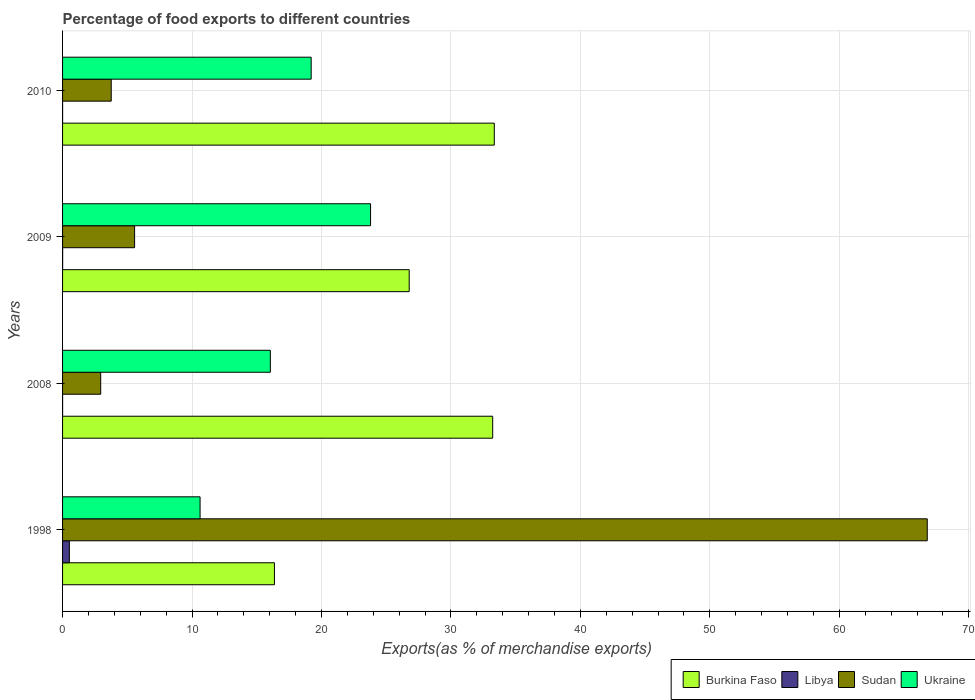How many different coloured bars are there?
Ensure brevity in your answer.  4. How many groups of bars are there?
Your response must be concise. 4. How many bars are there on the 1st tick from the top?
Make the answer very short. 4. What is the percentage of exports to different countries in Sudan in 2010?
Keep it short and to the point. 3.76. Across all years, what is the maximum percentage of exports to different countries in Ukraine?
Keep it short and to the point. 23.79. Across all years, what is the minimum percentage of exports to different countries in Sudan?
Provide a succinct answer. 2.95. In which year was the percentage of exports to different countries in Burkina Faso maximum?
Give a very brief answer. 2010. What is the total percentage of exports to different countries in Ukraine in the graph?
Offer a terse response. 69.66. What is the difference between the percentage of exports to different countries in Burkina Faso in 1998 and that in 2008?
Offer a terse response. -16.86. What is the difference between the percentage of exports to different countries in Burkina Faso in 2008 and the percentage of exports to different countries in Sudan in 1998?
Provide a short and direct response. -33.57. What is the average percentage of exports to different countries in Ukraine per year?
Your answer should be compact. 17.42. In the year 2008, what is the difference between the percentage of exports to different countries in Ukraine and percentage of exports to different countries in Libya?
Provide a short and direct response. 16.05. What is the ratio of the percentage of exports to different countries in Sudan in 2009 to that in 2010?
Provide a short and direct response. 1.48. What is the difference between the highest and the second highest percentage of exports to different countries in Burkina Faso?
Your answer should be very brief. 0.12. What is the difference between the highest and the lowest percentage of exports to different countries in Sudan?
Your answer should be very brief. 63.85. In how many years, is the percentage of exports to different countries in Sudan greater than the average percentage of exports to different countries in Sudan taken over all years?
Your response must be concise. 1. Is the sum of the percentage of exports to different countries in Sudan in 1998 and 2010 greater than the maximum percentage of exports to different countries in Ukraine across all years?
Your answer should be compact. Yes. Is it the case that in every year, the sum of the percentage of exports to different countries in Ukraine and percentage of exports to different countries in Burkina Faso is greater than the sum of percentage of exports to different countries in Libya and percentage of exports to different countries in Sudan?
Offer a very short reply. Yes. What does the 2nd bar from the top in 2010 represents?
Keep it short and to the point. Sudan. What does the 2nd bar from the bottom in 2009 represents?
Your answer should be very brief. Libya. Is it the case that in every year, the sum of the percentage of exports to different countries in Libya and percentage of exports to different countries in Sudan is greater than the percentage of exports to different countries in Burkina Faso?
Ensure brevity in your answer.  No. How many bars are there?
Give a very brief answer. 16. Does the graph contain grids?
Your answer should be compact. Yes. Where does the legend appear in the graph?
Provide a short and direct response. Bottom right. How many legend labels are there?
Provide a succinct answer. 4. What is the title of the graph?
Offer a terse response. Percentage of food exports to different countries. What is the label or title of the X-axis?
Provide a succinct answer. Exports(as % of merchandise exports). What is the Exports(as % of merchandise exports) in Burkina Faso in 1998?
Give a very brief answer. 16.37. What is the Exports(as % of merchandise exports) of Libya in 1998?
Provide a short and direct response. 0.53. What is the Exports(as % of merchandise exports) of Sudan in 1998?
Your answer should be very brief. 66.79. What is the Exports(as % of merchandise exports) in Ukraine in 1998?
Provide a short and direct response. 10.62. What is the Exports(as % of merchandise exports) of Burkina Faso in 2008?
Keep it short and to the point. 33.22. What is the Exports(as % of merchandise exports) in Libya in 2008?
Offer a very short reply. 0. What is the Exports(as % of merchandise exports) of Sudan in 2008?
Ensure brevity in your answer.  2.95. What is the Exports(as % of merchandise exports) of Ukraine in 2008?
Provide a succinct answer. 16.05. What is the Exports(as % of merchandise exports) of Burkina Faso in 2009?
Offer a terse response. 26.78. What is the Exports(as % of merchandise exports) of Libya in 2009?
Keep it short and to the point. 0.01. What is the Exports(as % of merchandise exports) of Sudan in 2009?
Offer a very short reply. 5.56. What is the Exports(as % of merchandise exports) of Ukraine in 2009?
Provide a succinct answer. 23.79. What is the Exports(as % of merchandise exports) of Burkina Faso in 2010?
Make the answer very short. 33.35. What is the Exports(as % of merchandise exports) of Libya in 2010?
Ensure brevity in your answer.  0. What is the Exports(as % of merchandise exports) in Sudan in 2010?
Ensure brevity in your answer.  3.76. What is the Exports(as % of merchandise exports) of Ukraine in 2010?
Make the answer very short. 19.2. Across all years, what is the maximum Exports(as % of merchandise exports) in Burkina Faso?
Provide a short and direct response. 33.35. Across all years, what is the maximum Exports(as % of merchandise exports) of Libya?
Provide a short and direct response. 0.53. Across all years, what is the maximum Exports(as % of merchandise exports) of Sudan?
Ensure brevity in your answer.  66.79. Across all years, what is the maximum Exports(as % of merchandise exports) in Ukraine?
Ensure brevity in your answer.  23.79. Across all years, what is the minimum Exports(as % of merchandise exports) in Burkina Faso?
Ensure brevity in your answer.  16.37. Across all years, what is the minimum Exports(as % of merchandise exports) in Libya?
Keep it short and to the point. 0. Across all years, what is the minimum Exports(as % of merchandise exports) of Sudan?
Provide a short and direct response. 2.95. Across all years, what is the minimum Exports(as % of merchandise exports) in Ukraine?
Your answer should be very brief. 10.62. What is the total Exports(as % of merchandise exports) of Burkina Faso in the graph?
Your answer should be very brief. 109.71. What is the total Exports(as % of merchandise exports) in Libya in the graph?
Your answer should be compact. 0.54. What is the total Exports(as % of merchandise exports) in Sudan in the graph?
Offer a very short reply. 79.06. What is the total Exports(as % of merchandise exports) of Ukraine in the graph?
Provide a short and direct response. 69.66. What is the difference between the Exports(as % of merchandise exports) of Burkina Faso in 1998 and that in 2008?
Your answer should be very brief. -16.86. What is the difference between the Exports(as % of merchandise exports) in Libya in 1998 and that in 2008?
Provide a succinct answer. 0.52. What is the difference between the Exports(as % of merchandise exports) in Sudan in 1998 and that in 2008?
Provide a short and direct response. 63.85. What is the difference between the Exports(as % of merchandise exports) in Ukraine in 1998 and that in 2008?
Give a very brief answer. -5.43. What is the difference between the Exports(as % of merchandise exports) of Burkina Faso in 1998 and that in 2009?
Keep it short and to the point. -10.41. What is the difference between the Exports(as % of merchandise exports) of Libya in 1998 and that in 2009?
Provide a succinct answer. 0.52. What is the difference between the Exports(as % of merchandise exports) in Sudan in 1998 and that in 2009?
Provide a short and direct response. 61.23. What is the difference between the Exports(as % of merchandise exports) in Ukraine in 1998 and that in 2009?
Keep it short and to the point. -13.17. What is the difference between the Exports(as % of merchandise exports) of Burkina Faso in 1998 and that in 2010?
Your answer should be very brief. -16.98. What is the difference between the Exports(as % of merchandise exports) of Libya in 1998 and that in 2010?
Give a very brief answer. 0.52. What is the difference between the Exports(as % of merchandise exports) of Sudan in 1998 and that in 2010?
Make the answer very short. 63.03. What is the difference between the Exports(as % of merchandise exports) in Ukraine in 1998 and that in 2010?
Offer a very short reply. -8.58. What is the difference between the Exports(as % of merchandise exports) in Burkina Faso in 2008 and that in 2009?
Your answer should be very brief. 6.45. What is the difference between the Exports(as % of merchandise exports) of Libya in 2008 and that in 2009?
Your answer should be very brief. -0. What is the difference between the Exports(as % of merchandise exports) in Sudan in 2008 and that in 2009?
Your answer should be very brief. -2.62. What is the difference between the Exports(as % of merchandise exports) in Ukraine in 2008 and that in 2009?
Ensure brevity in your answer.  -7.74. What is the difference between the Exports(as % of merchandise exports) in Burkina Faso in 2008 and that in 2010?
Offer a very short reply. -0.12. What is the difference between the Exports(as % of merchandise exports) in Libya in 2008 and that in 2010?
Your answer should be very brief. 0. What is the difference between the Exports(as % of merchandise exports) in Sudan in 2008 and that in 2010?
Keep it short and to the point. -0.81. What is the difference between the Exports(as % of merchandise exports) of Ukraine in 2008 and that in 2010?
Keep it short and to the point. -3.15. What is the difference between the Exports(as % of merchandise exports) in Burkina Faso in 2009 and that in 2010?
Offer a very short reply. -6.57. What is the difference between the Exports(as % of merchandise exports) of Libya in 2009 and that in 2010?
Provide a short and direct response. 0. What is the difference between the Exports(as % of merchandise exports) of Sudan in 2009 and that in 2010?
Ensure brevity in your answer.  1.81. What is the difference between the Exports(as % of merchandise exports) of Ukraine in 2009 and that in 2010?
Ensure brevity in your answer.  4.59. What is the difference between the Exports(as % of merchandise exports) of Burkina Faso in 1998 and the Exports(as % of merchandise exports) of Libya in 2008?
Keep it short and to the point. 16.36. What is the difference between the Exports(as % of merchandise exports) in Burkina Faso in 1998 and the Exports(as % of merchandise exports) in Sudan in 2008?
Make the answer very short. 13.42. What is the difference between the Exports(as % of merchandise exports) of Burkina Faso in 1998 and the Exports(as % of merchandise exports) of Ukraine in 2008?
Make the answer very short. 0.32. What is the difference between the Exports(as % of merchandise exports) of Libya in 1998 and the Exports(as % of merchandise exports) of Sudan in 2008?
Make the answer very short. -2.42. What is the difference between the Exports(as % of merchandise exports) in Libya in 1998 and the Exports(as % of merchandise exports) in Ukraine in 2008?
Offer a very short reply. -15.52. What is the difference between the Exports(as % of merchandise exports) of Sudan in 1998 and the Exports(as % of merchandise exports) of Ukraine in 2008?
Your answer should be compact. 50.74. What is the difference between the Exports(as % of merchandise exports) in Burkina Faso in 1998 and the Exports(as % of merchandise exports) in Libya in 2009?
Offer a very short reply. 16.36. What is the difference between the Exports(as % of merchandise exports) in Burkina Faso in 1998 and the Exports(as % of merchandise exports) in Sudan in 2009?
Ensure brevity in your answer.  10.8. What is the difference between the Exports(as % of merchandise exports) in Burkina Faso in 1998 and the Exports(as % of merchandise exports) in Ukraine in 2009?
Provide a succinct answer. -7.42. What is the difference between the Exports(as % of merchandise exports) in Libya in 1998 and the Exports(as % of merchandise exports) in Sudan in 2009?
Ensure brevity in your answer.  -5.04. What is the difference between the Exports(as % of merchandise exports) in Libya in 1998 and the Exports(as % of merchandise exports) in Ukraine in 2009?
Provide a short and direct response. -23.26. What is the difference between the Exports(as % of merchandise exports) in Sudan in 1998 and the Exports(as % of merchandise exports) in Ukraine in 2009?
Provide a succinct answer. 43. What is the difference between the Exports(as % of merchandise exports) in Burkina Faso in 1998 and the Exports(as % of merchandise exports) in Libya in 2010?
Your response must be concise. 16.36. What is the difference between the Exports(as % of merchandise exports) in Burkina Faso in 1998 and the Exports(as % of merchandise exports) in Sudan in 2010?
Give a very brief answer. 12.61. What is the difference between the Exports(as % of merchandise exports) in Burkina Faso in 1998 and the Exports(as % of merchandise exports) in Ukraine in 2010?
Provide a short and direct response. -2.84. What is the difference between the Exports(as % of merchandise exports) of Libya in 1998 and the Exports(as % of merchandise exports) of Sudan in 2010?
Keep it short and to the point. -3.23. What is the difference between the Exports(as % of merchandise exports) in Libya in 1998 and the Exports(as % of merchandise exports) in Ukraine in 2010?
Keep it short and to the point. -18.68. What is the difference between the Exports(as % of merchandise exports) in Sudan in 1998 and the Exports(as % of merchandise exports) in Ukraine in 2010?
Provide a succinct answer. 47.59. What is the difference between the Exports(as % of merchandise exports) in Burkina Faso in 2008 and the Exports(as % of merchandise exports) in Libya in 2009?
Keep it short and to the point. 33.22. What is the difference between the Exports(as % of merchandise exports) of Burkina Faso in 2008 and the Exports(as % of merchandise exports) of Sudan in 2009?
Your answer should be compact. 27.66. What is the difference between the Exports(as % of merchandise exports) of Burkina Faso in 2008 and the Exports(as % of merchandise exports) of Ukraine in 2009?
Offer a terse response. 9.43. What is the difference between the Exports(as % of merchandise exports) of Libya in 2008 and the Exports(as % of merchandise exports) of Sudan in 2009?
Provide a short and direct response. -5.56. What is the difference between the Exports(as % of merchandise exports) in Libya in 2008 and the Exports(as % of merchandise exports) in Ukraine in 2009?
Keep it short and to the point. -23.79. What is the difference between the Exports(as % of merchandise exports) of Sudan in 2008 and the Exports(as % of merchandise exports) of Ukraine in 2009?
Ensure brevity in your answer.  -20.84. What is the difference between the Exports(as % of merchandise exports) of Burkina Faso in 2008 and the Exports(as % of merchandise exports) of Libya in 2010?
Your answer should be very brief. 33.22. What is the difference between the Exports(as % of merchandise exports) of Burkina Faso in 2008 and the Exports(as % of merchandise exports) of Sudan in 2010?
Your response must be concise. 29.47. What is the difference between the Exports(as % of merchandise exports) in Burkina Faso in 2008 and the Exports(as % of merchandise exports) in Ukraine in 2010?
Provide a succinct answer. 14.02. What is the difference between the Exports(as % of merchandise exports) of Libya in 2008 and the Exports(as % of merchandise exports) of Sudan in 2010?
Your answer should be compact. -3.76. What is the difference between the Exports(as % of merchandise exports) of Libya in 2008 and the Exports(as % of merchandise exports) of Ukraine in 2010?
Provide a succinct answer. -19.2. What is the difference between the Exports(as % of merchandise exports) of Sudan in 2008 and the Exports(as % of merchandise exports) of Ukraine in 2010?
Keep it short and to the point. -16.26. What is the difference between the Exports(as % of merchandise exports) in Burkina Faso in 2009 and the Exports(as % of merchandise exports) in Libya in 2010?
Give a very brief answer. 26.77. What is the difference between the Exports(as % of merchandise exports) in Burkina Faso in 2009 and the Exports(as % of merchandise exports) in Sudan in 2010?
Provide a succinct answer. 23.02. What is the difference between the Exports(as % of merchandise exports) in Burkina Faso in 2009 and the Exports(as % of merchandise exports) in Ukraine in 2010?
Give a very brief answer. 7.57. What is the difference between the Exports(as % of merchandise exports) in Libya in 2009 and the Exports(as % of merchandise exports) in Sudan in 2010?
Ensure brevity in your answer.  -3.75. What is the difference between the Exports(as % of merchandise exports) of Libya in 2009 and the Exports(as % of merchandise exports) of Ukraine in 2010?
Offer a terse response. -19.2. What is the difference between the Exports(as % of merchandise exports) of Sudan in 2009 and the Exports(as % of merchandise exports) of Ukraine in 2010?
Ensure brevity in your answer.  -13.64. What is the average Exports(as % of merchandise exports) of Burkina Faso per year?
Keep it short and to the point. 27.43. What is the average Exports(as % of merchandise exports) of Libya per year?
Your answer should be compact. 0.13. What is the average Exports(as % of merchandise exports) in Sudan per year?
Make the answer very short. 19.76. What is the average Exports(as % of merchandise exports) of Ukraine per year?
Your answer should be very brief. 17.42. In the year 1998, what is the difference between the Exports(as % of merchandise exports) of Burkina Faso and Exports(as % of merchandise exports) of Libya?
Your answer should be compact. 15.84. In the year 1998, what is the difference between the Exports(as % of merchandise exports) of Burkina Faso and Exports(as % of merchandise exports) of Sudan?
Make the answer very short. -50.42. In the year 1998, what is the difference between the Exports(as % of merchandise exports) in Burkina Faso and Exports(as % of merchandise exports) in Ukraine?
Ensure brevity in your answer.  5.74. In the year 1998, what is the difference between the Exports(as % of merchandise exports) of Libya and Exports(as % of merchandise exports) of Sudan?
Provide a succinct answer. -66.27. In the year 1998, what is the difference between the Exports(as % of merchandise exports) of Libya and Exports(as % of merchandise exports) of Ukraine?
Give a very brief answer. -10.1. In the year 1998, what is the difference between the Exports(as % of merchandise exports) in Sudan and Exports(as % of merchandise exports) in Ukraine?
Your answer should be very brief. 56.17. In the year 2008, what is the difference between the Exports(as % of merchandise exports) in Burkina Faso and Exports(as % of merchandise exports) in Libya?
Offer a very short reply. 33.22. In the year 2008, what is the difference between the Exports(as % of merchandise exports) in Burkina Faso and Exports(as % of merchandise exports) in Sudan?
Your answer should be very brief. 30.28. In the year 2008, what is the difference between the Exports(as % of merchandise exports) of Burkina Faso and Exports(as % of merchandise exports) of Ukraine?
Your response must be concise. 17.17. In the year 2008, what is the difference between the Exports(as % of merchandise exports) of Libya and Exports(as % of merchandise exports) of Sudan?
Provide a short and direct response. -2.94. In the year 2008, what is the difference between the Exports(as % of merchandise exports) in Libya and Exports(as % of merchandise exports) in Ukraine?
Provide a short and direct response. -16.05. In the year 2008, what is the difference between the Exports(as % of merchandise exports) of Sudan and Exports(as % of merchandise exports) of Ukraine?
Make the answer very short. -13.1. In the year 2009, what is the difference between the Exports(as % of merchandise exports) in Burkina Faso and Exports(as % of merchandise exports) in Libya?
Ensure brevity in your answer.  26.77. In the year 2009, what is the difference between the Exports(as % of merchandise exports) of Burkina Faso and Exports(as % of merchandise exports) of Sudan?
Your answer should be compact. 21.21. In the year 2009, what is the difference between the Exports(as % of merchandise exports) of Burkina Faso and Exports(as % of merchandise exports) of Ukraine?
Ensure brevity in your answer.  2.98. In the year 2009, what is the difference between the Exports(as % of merchandise exports) in Libya and Exports(as % of merchandise exports) in Sudan?
Provide a succinct answer. -5.56. In the year 2009, what is the difference between the Exports(as % of merchandise exports) of Libya and Exports(as % of merchandise exports) of Ukraine?
Give a very brief answer. -23.78. In the year 2009, what is the difference between the Exports(as % of merchandise exports) in Sudan and Exports(as % of merchandise exports) in Ukraine?
Provide a short and direct response. -18.23. In the year 2010, what is the difference between the Exports(as % of merchandise exports) of Burkina Faso and Exports(as % of merchandise exports) of Libya?
Provide a short and direct response. 33.35. In the year 2010, what is the difference between the Exports(as % of merchandise exports) in Burkina Faso and Exports(as % of merchandise exports) in Sudan?
Ensure brevity in your answer.  29.59. In the year 2010, what is the difference between the Exports(as % of merchandise exports) of Burkina Faso and Exports(as % of merchandise exports) of Ukraine?
Give a very brief answer. 14.14. In the year 2010, what is the difference between the Exports(as % of merchandise exports) in Libya and Exports(as % of merchandise exports) in Sudan?
Your response must be concise. -3.76. In the year 2010, what is the difference between the Exports(as % of merchandise exports) of Libya and Exports(as % of merchandise exports) of Ukraine?
Give a very brief answer. -19.2. In the year 2010, what is the difference between the Exports(as % of merchandise exports) in Sudan and Exports(as % of merchandise exports) in Ukraine?
Provide a short and direct response. -15.45. What is the ratio of the Exports(as % of merchandise exports) in Burkina Faso in 1998 to that in 2008?
Offer a terse response. 0.49. What is the ratio of the Exports(as % of merchandise exports) in Libya in 1998 to that in 2008?
Make the answer very short. 203.84. What is the ratio of the Exports(as % of merchandise exports) in Sudan in 1998 to that in 2008?
Your answer should be compact. 22.67. What is the ratio of the Exports(as % of merchandise exports) in Ukraine in 1998 to that in 2008?
Ensure brevity in your answer.  0.66. What is the ratio of the Exports(as % of merchandise exports) of Burkina Faso in 1998 to that in 2009?
Ensure brevity in your answer.  0.61. What is the ratio of the Exports(as % of merchandise exports) of Libya in 1998 to that in 2009?
Keep it short and to the point. 89.4. What is the ratio of the Exports(as % of merchandise exports) in Sudan in 1998 to that in 2009?
Ensure brevity in your answer.  12. What is the ratio of the Exports(as % of merchandise exports) in Ukraine in 1998 to that in 2009?
Ensure brevity in your answer.  0.45. What is the ratio of the Exports(as % of merchandise exports) of Burkina Faso in 1998 to that in 2010?
Offer a terse response. 0.49. What is the ratio of the Exports(as % of merchandise exports) of Libya in 1998 to that in 2010?
Provide a short and direct response. 270.47. What is the ratio of the Exports(as % of merchandise exports) of Sudan in 1998 to that in 2010?
Offer a very short reply. 17.77. What is the ratio of the Exports(as % of merchandise exports) of Ukraine in 1998 to that in 2010?
Provide a short and direct response. 0.55. What is the ratio of the Exports(as % of merchandise exports) of Burkina Faso in 2008 to that in 2009?
Offer a terse response. 1.24. What is the ratio of the Exports(as % of merchandise exports) in Libya in 2008 to that in 2009?
Give a very brief answer. 0.44. What is the ratio of the Exports(as % of merchandise exports) of Sudan in 2008 to that in 2009?
Offer a very short reply. 0.53. What is the ratio of the Exports(as % of merchandise exports) in Ukraine in 2008 to that in 2009?
Your response must be concise. 0.67. What is the ratio of the Exports(as % of merchandise exports) in Burkina Faso in 2008 to that in 2010?
Give a very brief answer. 1. What is the ratio of the Exports(as % of merchandise exports) in Libya in 2008 to that in 2010?
Your answer should be compact. 1.33. What is the ratio of the Exports(as % of merchandise exports) of Sudan in 2008 to that in 2010?
Provide a short and direct response. 0.78. What is the ratio of the Exports(as % of merchandise exports) of Ukraine in 2008 to that in 2010?
Ensure brevity in your answer.  0.84. What is the ratio of the Exports(as % of merchandise exports) of Burkina Faso in 2009 to that in 2010?
Give a very brief answer. 0.8. What is the ratio of the Exports(as % of merchandise exports) in Libya in 2009 to that in 2010?
Ensure brevity in your answer.  3.03. What is the ratio of the Exports(as % of merchandise exports) in Sudan in 2009 to that in 2010?
Your answer should be very brief. 1.48. What is the ratio of the Exports(as % of merchandise exports) of Ukraine in 2009 to that in 2010?
Keep it short and to the point. 1.24. What is the difference between the highest and the second highest Exports(as % of merchandise exports) in Burkina Faso?
Your response must be concise. 0.12. What is the difference between the highest and the second highest Exports(as % of merchandise exports) of Libya?
Make the answer very short. 0.52. What is the difference between the highest and the second highest Exports(as % of merchandise exports) of Sudan?
Keep it short and to the point. 61.23. What is the difference between the highest and the second highest Exports(as % of merchandise exports) of Ukraine?
Your answer should be compact. 4.59. What is the difference between the highest and the lowest Exports(as % of merchandise exports) in Burkina Faso?
Give a very brief answer. 16.98. What is the difference between the highest and the lowest Exports(as % of merchandise exports) of Libya?
Provide a succinct answer. 0.52. What is the difference between the highest and the lowest Exports(as % of merchandise exports) in Sudan?
Provide a short and direct response. 63.85. What is the difference between the highest and the lowest Exports(as % of merchandise exports) in Ukraine?
Provide a short and direct response. 13.17. 